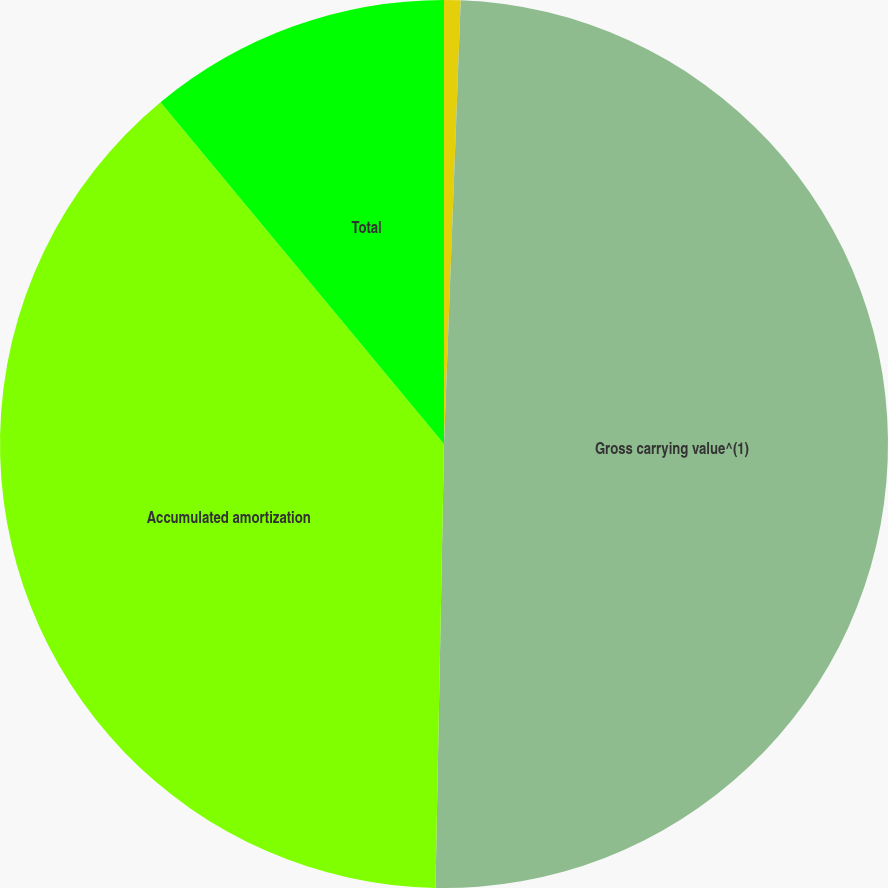Convert chart to OTSL. <chart><loc_0><loc_0><loc_500><loc_500><pie_chart><fcel>(DOLLARS IN THOUSANDS)<fcel>Gross carrying value^(1)<fcel>Accumulated amortization<fcel>Total<nl><fcel>0.6%<fcel>49.7%<fcel>38.67%<fcel>11.02%<nl></chart> 